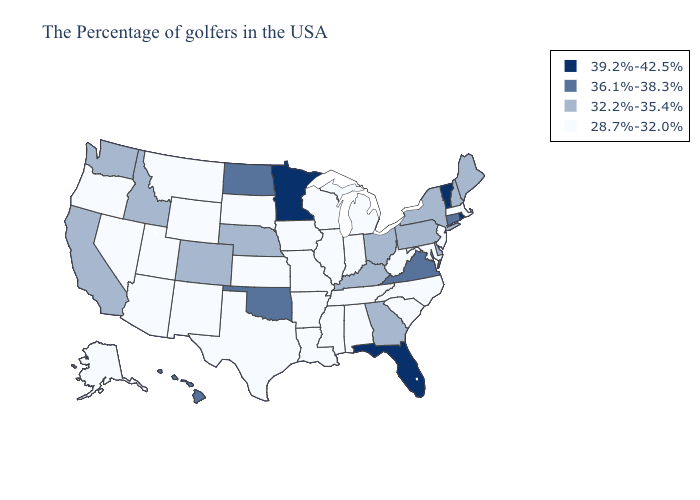Name the states that have a value in the range 36.1%-38.3%?
Short answer required. Connecticut, Virginia, Oklahoma, North Dakota, Hawaii. Name the states that have a value in the range 39.2%-42.5%?
Answer briefly. Rhode Island, Vermont, Florida, Minnesota. Does Nebraska have the same value as Florida?
Quick response, please. No. What is the highest value in states that border Colorado?
Quick response, please. 36.1%-38.3%. Name the states that have a value in the range 36.1%-38.3%?
Short answer required. Connecticut, Virginia, Oklahoma, North Dakota, Hawaii. Among the states that border Louisiana , which have the highest value?
Give a very brief answer. Mississippi, Arkansas, Texas. What is the lowest value in states that border Iowa?
Keep it brief. 28.7%-32.0%. Among the states that border North Dakota , does Montana have the lowest value?
Give a very brief answer. Yes. Does Virginia have the same value as Michigan?
Write a very short answer. No. Among the states that border Alabama , does Mississippi have the highest value?
Answer briefly. No. Is the legend a continuous bar?
Keep it brief. No. Name the states that have a value in the range 36.1%-38.3%?
Write a very short answer. Connecticut, Virginia, Oklahoma, North Dakota, Hawaii. Does North Carolina have a lower value than Ohio?
Short answer required. Yes. Which states have the lowest value in the Northeast?
Answer briefly. Massachusetts, New Jersey. What is the lowest value in the MidWest?
Concise answer only. 28.7%-32.0%. 